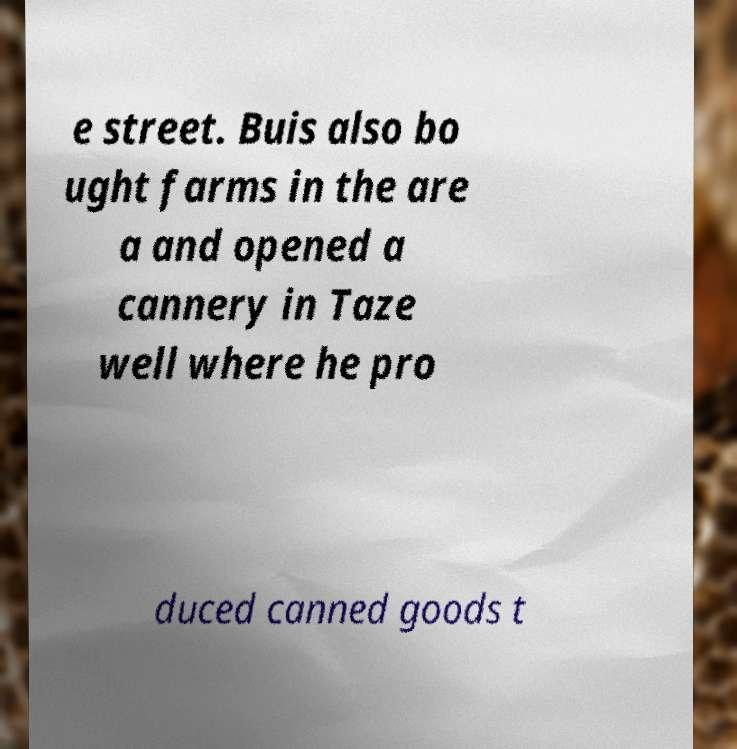Could you extract and type out the text from this image? e street. Buis also bo ught farms in the are a and opened a cannery in Taze well where he pro duced canned goods t 